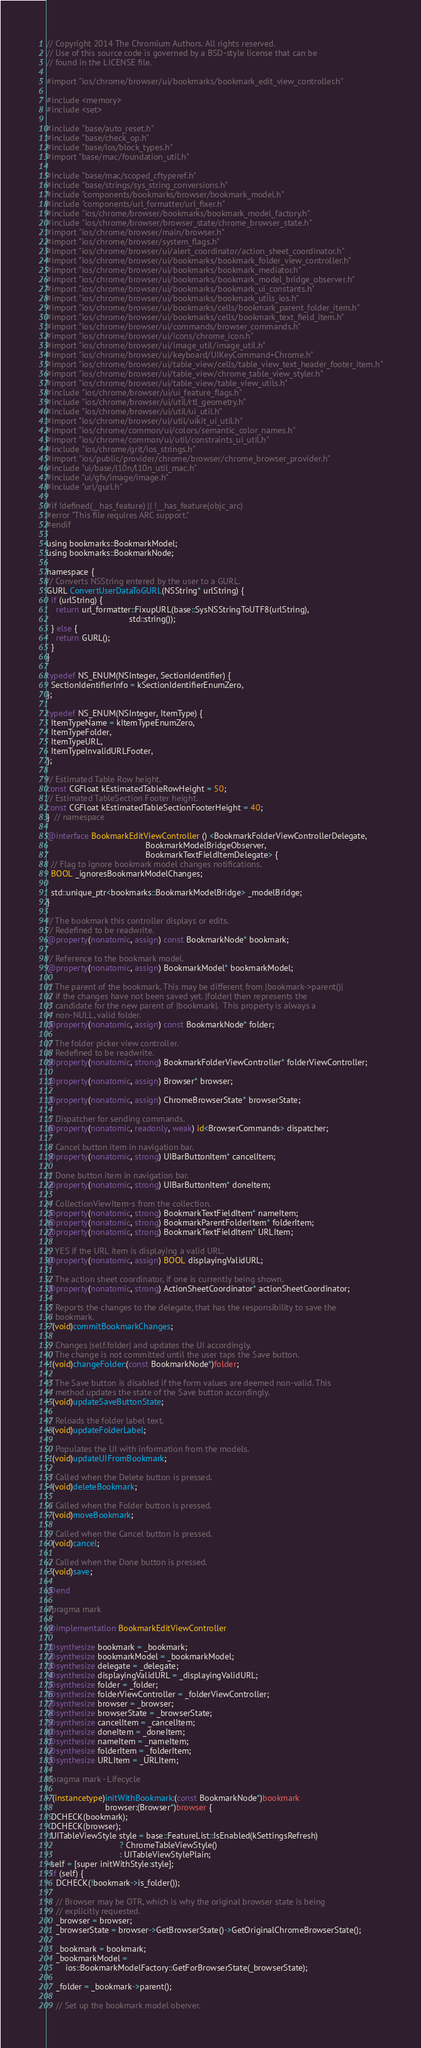<code> <loc_0><loc_0><loc_500><loc_500><_ObjectiveC_>// Copyright 2014 The Chromium Authors. All rights reserved.
// Use of this source code is governed by a BSD-style license that can be
// found in the LICENSE file.

#import "ios/chrome/browser/ui/bookmarks/bookmark_edit_view_controller.h"

#include <memory>
#include <set>

#include "base/auto_reset.h"
#include "base/check_op.h"
#include "base/ios/block_types.h"
#import "base/mac/foundation_util.h"

#include "base/mac/scoped_cftyperef.h"
#include "base/strings/sys_string_conversions.h"
#include "components/bookmarks/browser/bookmark_model.h"
#include "components/url_formatter/url_fixer.h"
#include "ios/chrome/browser/bookmarks/bookmark_model_factory.h"
#include "ios/chrome/browser/browser_state/chrome_browser_state.h"
#import "ios/chrome/browser/main/browser.h"
#import "ios/chrome/browser/system_flags.h"
#import "ios/chrome/browser/ui/alert_coordinator/action_sheet_coordinator.h"
#import "ios/chrome/browser/ui/bookmarks/bookmark_folder_view_controller.h"
#import "ios/chrome/browser/ui/bookmarks/bookmark_mediator.h"
#import "ios/chrome/browser/ui/bookmarks/bookmark_model_bridge_observer.h"
#import "ios/chrome/browser/ui/bookmarks/bookmark_ui_constants.h"
#import "ios/chrome/browser/ui/bookmarks/bookmark_utils_ios.h"
#import "ios/chrome/browser/ui/bookmarks/cells/bookmark_parent_folder_item.h"
#import "ios/chrome/browser/ui/bookmarks/cells/bookmark_text_field_item.h"
#import "ios/chrome/browser/ui/commands/browser_commands.h"
#import "ios/chrome/browser/ui/icons/chrome_icon.h"
#import "ios/chrome/browser/ui/image_util/image_util.h"
#import "ios/chrome/browser/ui/keyboard/UIKeyCommand+Chrome.h"
#import "ios/chrome/browser/ui/table_view/cells/table_view_text_header_footer_item.h"
#import "ios/chrome/browser/ui/table_view/chrome_table_view_styler.h"
#import "ios/chrome/browser/ui/table_view/table_view_utils.h"
#include "ios/chrome/browser/ui/ui_feature_flags.h"
#include "ios/chrome/browser/ui/util/rtl_geometry.h"
#include "ios/chrome/browser/ui/util/ui_util.h"
#import "ios/chrome/browser/ui/util/uikit_ui_util.h"
#import "ios/chrome/common/ui/colors/semantic_color_names.h"
#import "ios/chrome/common/ui/util/constraints_ui_util.h"
#include "ios/chrome/grit/ios_strings.h"
#import "ios/public/provider/chrome/browser/chrome_browser_provider.h"
#include "ui/base/l10n/l10n_util_mac.h"
#include "ui/gfx/image/image.h"
#include "url/gurl.h"

#if !defined(__has_feature) || !__has_feature(objc_arc)
#error "This file requires ARC support."
#endif

using bookmarks::BookmarkModel;
using bookmarks::BookmarkNode;

namespace {
// Converts NSString entered by the user to a GURL.
GURL ConvertUserDataToGURL(NSString* urlString) {
  if (urlString) {
    return url_formatter::FixupURL(base::SysNSStringToUTF8(urlString),
                                   std::string());
  } else {
    return GURL();
  }
}

typedef NS_ENUM(NSInteger, SectionIdentifier) {
  SectionIdentifierInfo = kSectionIdentifierEnumZero,
};

typedef NS_ENUM(NSInteger, ItemType) {
  ItemTypeName = kItemTypeEnumZero,
  ItemTypeFolder,
  ItemTypeURL,
  ItemTypeInvalidURLFooter,
};

// Estimated Table Row height.
const CGFloat kEstimatedTableRowHeight = 50;
// Estimated TableSection Footer height.
const CGFloat kEstimatedTableSectionFooterHeight = 40;
}  // namespace

@interface BookmarkEditViewController () <BookmarkFolderViewControllerDelegate,
                                          BookmarkModelBridgeObserver,
                                          BookmarkTextFieldItemDelegate> {
  // Flag to ignore bookmark model changes notifications.
  BOOL _ignoresBookmarkModelChanges;

  std::unique_ptr<bookmarks::BookmarkModelBridge> _modelBridge;
}

// The bookmark this controller displays or edits.
// Redefined to be readwrite.
@property(nonatomic, assign) const BookmarkNode* bookmark;

// Reference to the bookmark model.
@property(nonatomic, assign) BookmarkModel* bookmarkModel;

// The parent of the bookmark. This may be different from |bookmark->parent()|
// if the changes have not been saved yet. |folder| then represents the
// candidate for the new parent of |bookmark|.  This property is always a
// non-NULL, valid folder.
@property(nonatomic, assign) const BookmarkNode* folder;

// The folder picker view controller.
// Redefined to be readwrite.
@property(nonatomic, strong) BookmarkFolderViewController* folderViewController;

@property(nonatomic, assign) Browser* browser;

@property(nonatomic, assign) ChromeBrowserState* browserState;

// Dispatcher for sending commands.
@property(nonatomic, readonly, weak) id<BrowserCommands> dispatcher;

// Cancel button item in navigation bar.
@property(nonatomic, strong) UIBarButtonItem* cancelItem;

// Done button item in navigation bar.
@property(nonatomic, strong) UIBarButtonItem* doneItem;

// CollectionViewItem-s from the collection.
@property(nonatomic, strong) BookmarkTextFieldItem* nameItem;
@property(nonatomic, strong) BookmarkParentFolderItem* folderItem;
@property(nonatomic, strong) BookmarkTextFieldItem* URLItem;

// YES if the URL item is displaying a valid URL.
@property(nonatomic, assign) BOOL displayingValidURL;

// The action sheet coordinator, if one is currently being shown.
@property(nonatomic, strong) ActionSheetCoordinator* actionSheetCoordinator;

// Reports the changes to the delegate, that has the responsibility to save the
// bookmark.
- (void)commitBookmarkChanges;

// Changes |self.folder| and updates the UI accordingly.
// The change is not committed until the user taps the Save button.
- (void)changeFolder:(const BookmarkNode*)folder;

// The Save button is disabled if the form values are deemed non-valid. This
// method updates the state of the Save button accordingly.
- (void)updateSaveButtonState;

// Reloads the folder label text.
- (void)updateFolderLabel;

// Populates the UI with information from the models.
- (void)updateUIFromBookmark;

// Called when the Delete button is pressed.
- (void)deleteBookmark;

// Called when the Folder button is pressed.
- (void)moveBookmark;

// Called when the Cancel button is pressed.
- (void)cancel;

// Called when the Done button is pressed.
- (void)save;

@end

#pragma mark

@implementation BookmarkEditViewController

@synthesize bookmark = _bookmark;
@synthesize bookmarkModel = _bookmarkModel;
@synthesize delegate = _delegate;
@synthesize displayingValidURL = _displayingValidURL;
@synthesize folder = _folder;
@synthesize folderViewController = _folderViewController;
@synthesize browser = _browser;
@synthesize browserState = _browserState;
@synthesize cancelItem = _cancelItem;
@synthesize doneItem = _doneItem;
@synthesize nameItem = _nameItem;
@synthesize folderItem = _folderItem;
@synthesize URLItem = _URLItem;

#pragma mark - Lifecycle

- (instancetype)initWithBookmark:(const BookmarkNode*)bookmark
                         browser:(Browser*)browser {
  DCHECK(bookmark);
  DCHECK(browser);
  UITableViewStyle style = base::FeatureList::IsEnabled(kSettingsRefresh)
                               ? ChromeTableViewStyle()
                               : UITableViewStylePlain;
  self = [super initWithStyle:style];
  if (self) {
    DCHECK(!bookmark->is_folder());

    // Browser may be OTR, which is why the original browser state is being
    // explicitly requested.
    _browser = browser;
    _browserState = browser->GetBrowserState()->GetOriginalChromeBrowserState();

    _bookmark = bookmark;
    _bookmarkModel =
        ios::BookmarkModelFactory::GetForBrowserState(_browserState);

    _folder = _bookmark->parent();

    // Set up the bookmark model oberver.</code> 